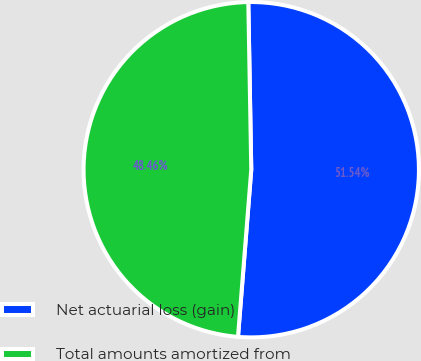Convert chart to OTSL. <chart><loc_0><loc_0><loc_500><loc_500><pie_chart><fcel>Net actuarial loss (gain)<fcel>Total amounts amortized from<nl><fcel>51.54%<fcel>48.46%<nl></chart> 